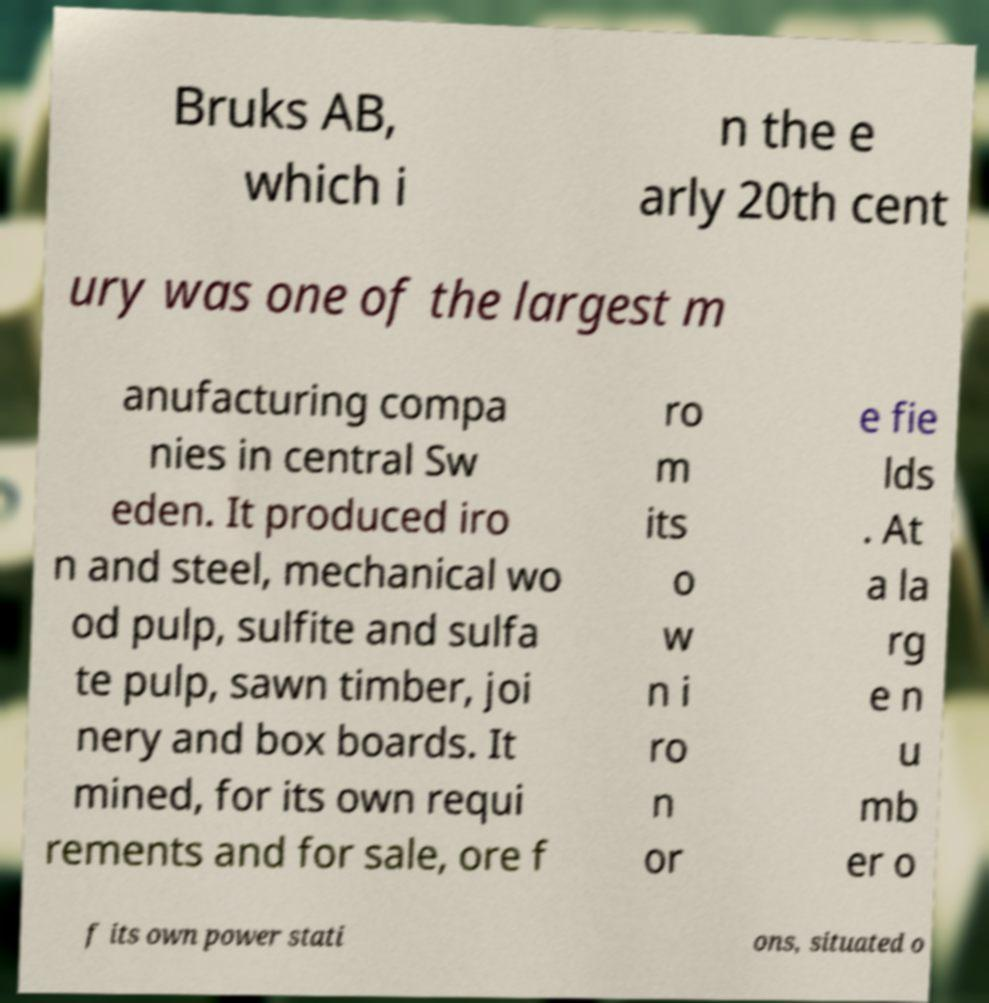What messages or text are displayed in this image? I need them in a readable, typed format. Bruks AB, which i n the e arly 20th cent ury was one of the largest m anufacturing compa nies in central Sw eden. It produced iro n and steel, mechanical wo od pulp, sulfite and sulfa te pulp, sawn timber, joi nery and box boards. It mined, for its own requi rements and for sale, ore f ro m its o w n i ro n or e fie lds . At a la rg e n u mb er o f its own power stati ons, situated o 